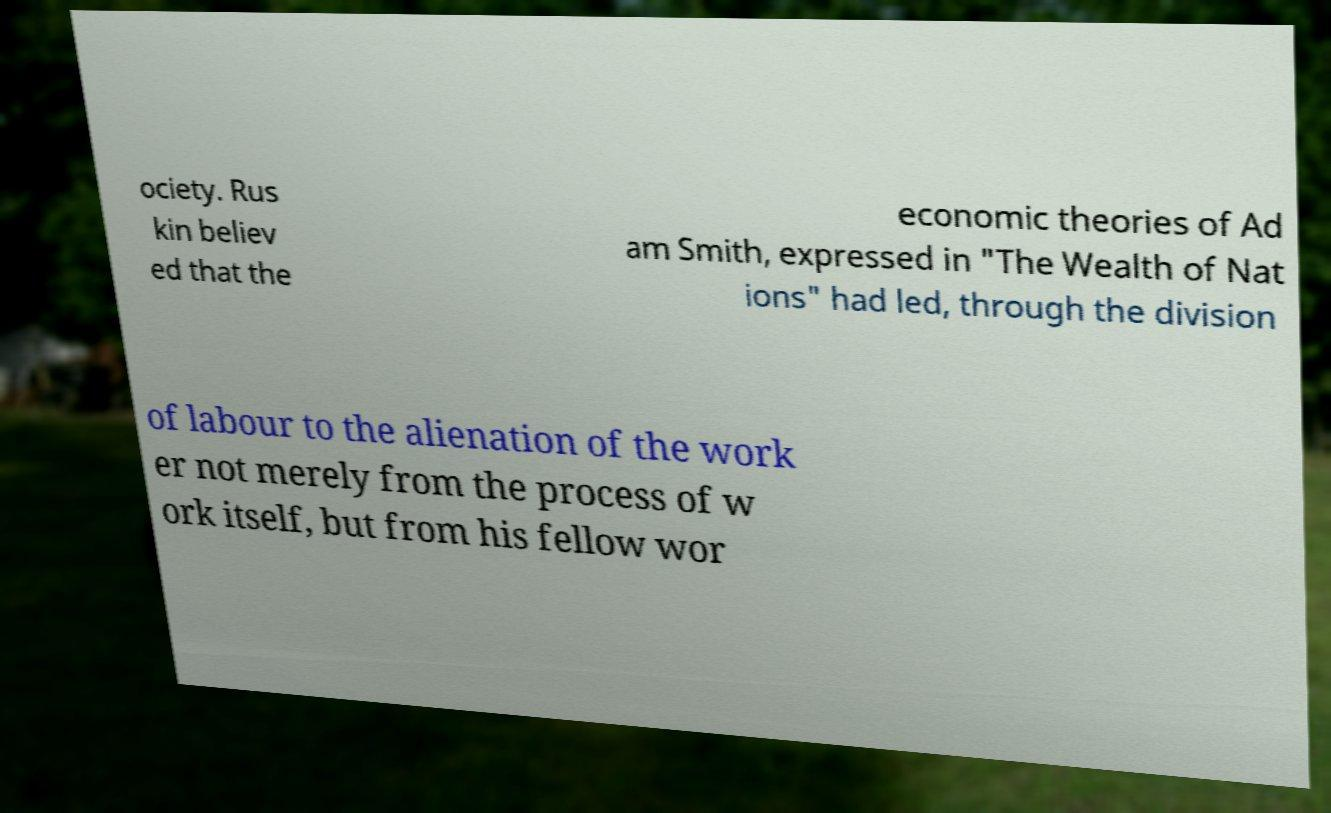I need the written content from this picture converted into text. Can you do that? ociety. Rus kin believ ed that the economic theories of Ad am Smith, expressed in "The Wealth of Nat ions" had led, through the division of labour to the alienation of the work er not merely from the process of w ork itself, but from his fellow wor 